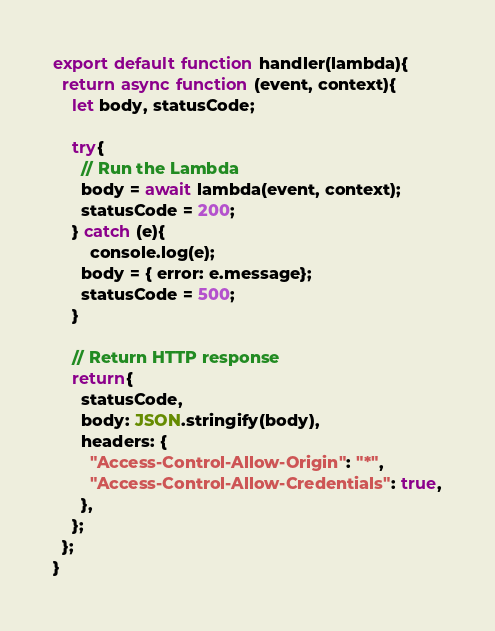<code> <loc_0><loc_0><loc_500><loc_500><_JavaScript_>export default function handler(lambda){
  return async function (event, context){
    let body, statusCode;

    try{
      // Run the Lambda
      body = await lambda(event, context);
      statusCode = 200;
    } catch (e){
        console.log(e);
      body = { error: e.message};
      statusCode = 500;
    }

    // Return HTTP response
    return{
      statusCode,
      body: JSON.stringify(body),
      headers: {
        "Access-Control-Allow-Origin": "*",
        "Access-Control-Allow-Credentials": true,
      },
    };
  };
}</code> 